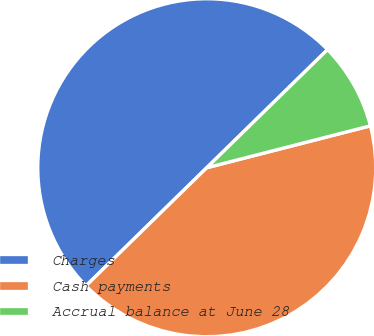Convert chart to OTSL. <chart><loc_0><loc_0><loc_500><loc_500><pie_chart><fcel>Charges<fcel>Cash payments<fcel>Accrual balance at June 28<nl><fcel>50.0%<fcel>41.67%<fcel>8.33%<nl></chart> 